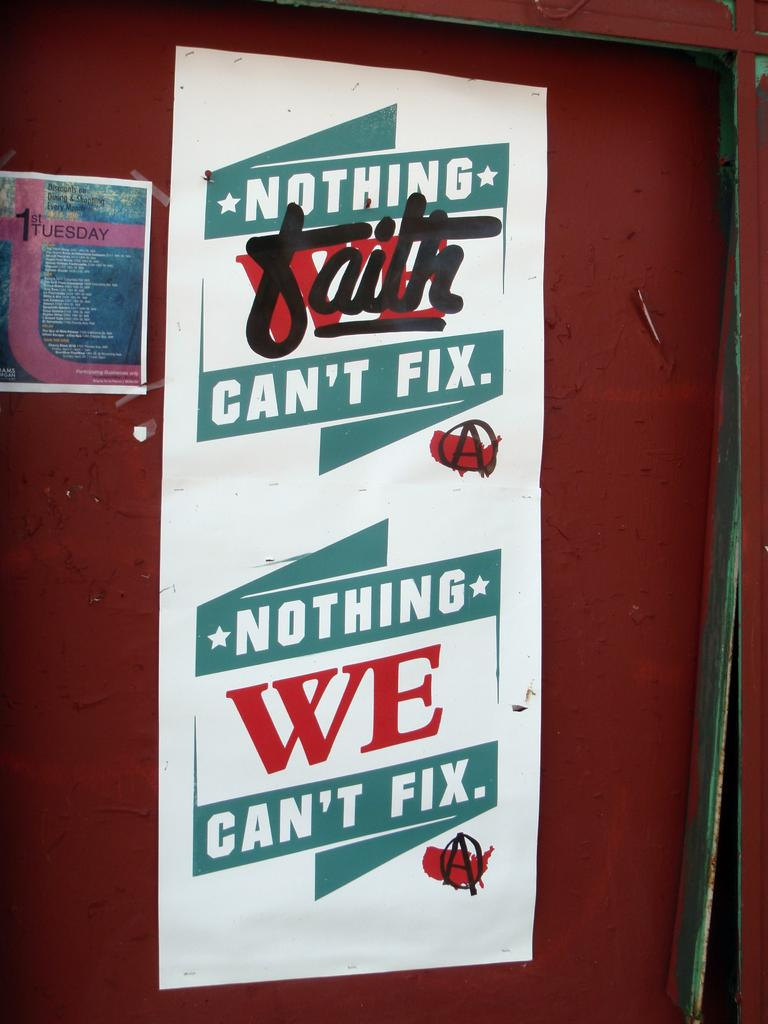<image>
Render a clear and concise summary of the photo. A poster that says "Nothing faith can't fix.  Nothing WE can't fix." 